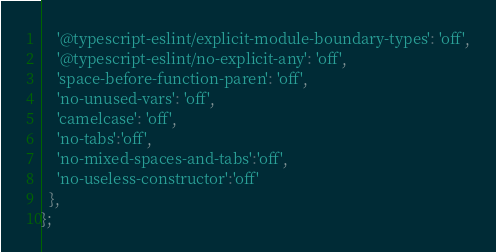Convert code to text. <code><loc_0><loc_0><loc_500><loc_500><_JavaScript_>    '@typescript-eslint/explicit-module-boundary-types': 'off',
    '@typescript-eslint/no-explicit-any': 'off',
    'space-before-function-paren': 'off',
    'no-unused-vars': 'off',
    'camelcase': 'off',
    'no-tabs':'off',
    'no-mixed-spaces-and-tabs':'off',
    'no-useless-constructor':'off'
  },
};
</code> 